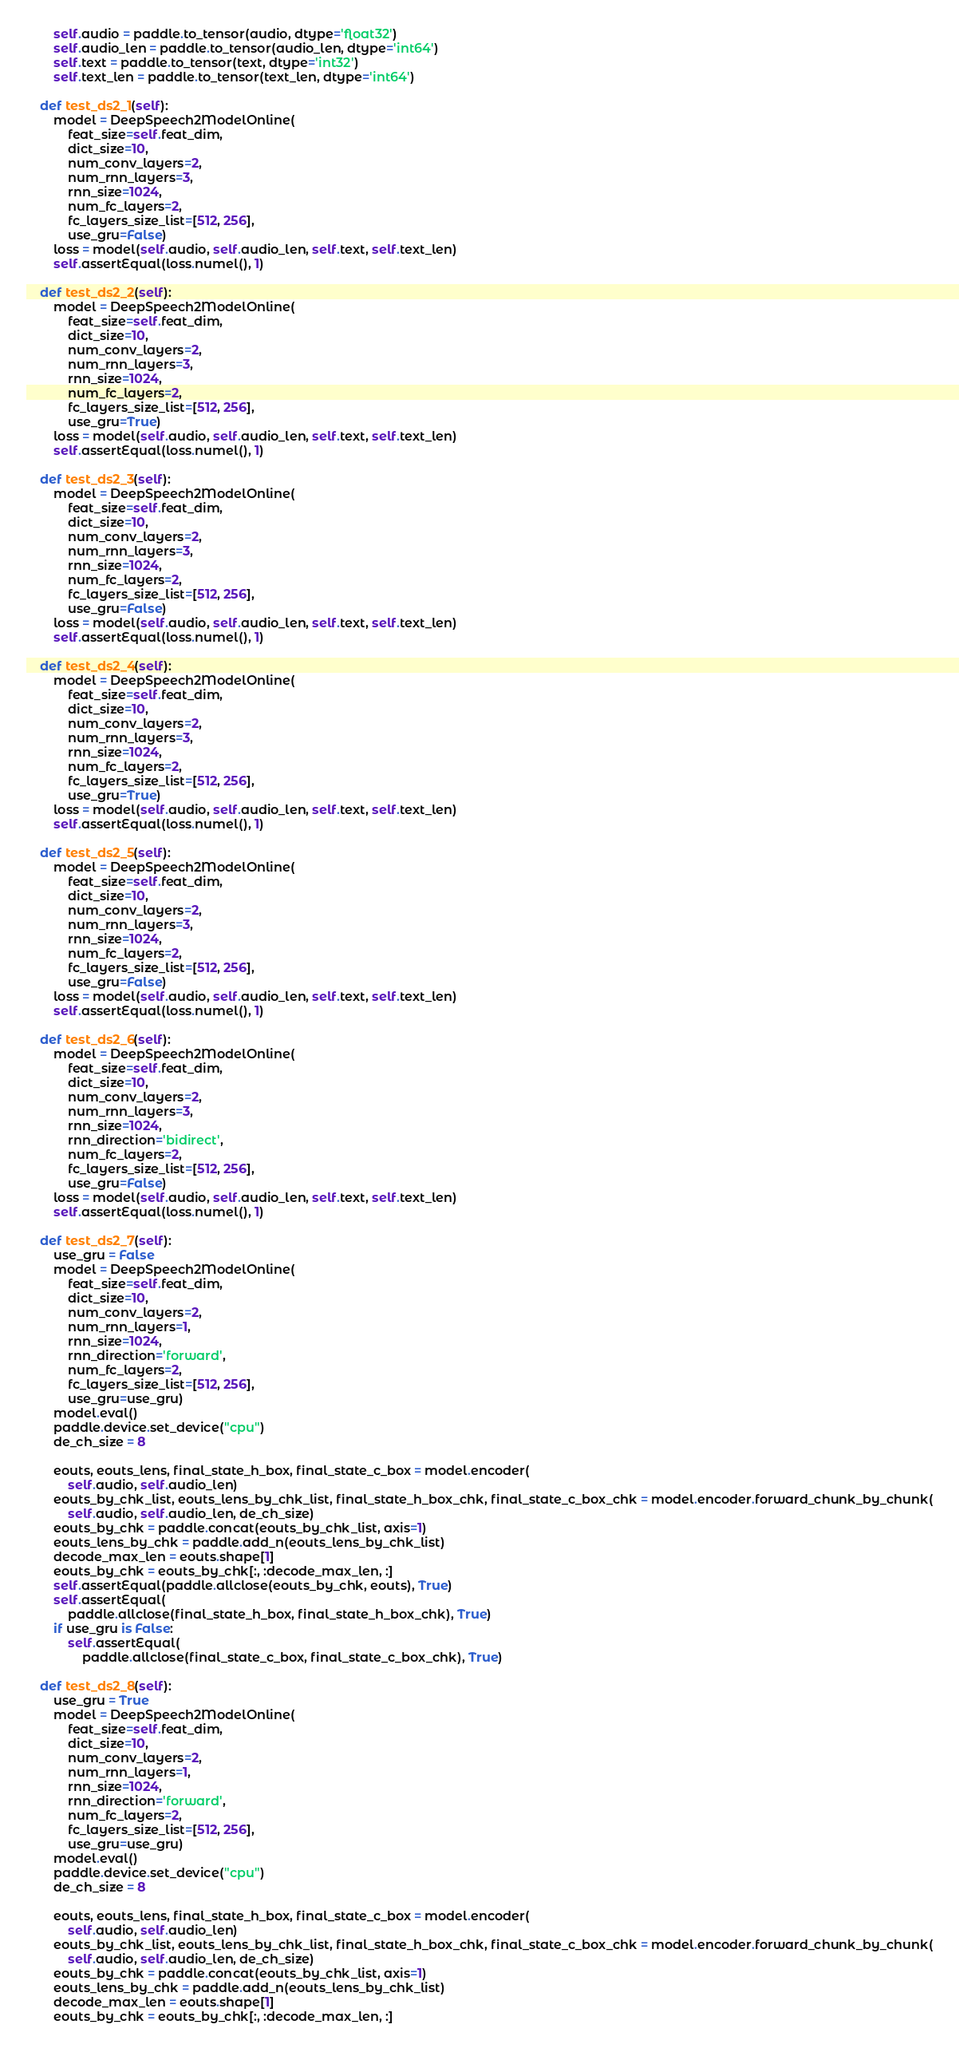<code> <loc_0><loc_0><loc_500><loc_500><_Python_>
        self.audio = paddle.to_tensor(audio, dtype='float32')
        self.audio_len = paddle.to_tensor(audio_len, dtype='int64')
        self.text = paddle.to_tensor(text, dtype='int32')
        self.text_len = paddle.to_tensor(text_len, dtype='int64')

    def test_ds2_1(self):
        model = DeepSpeech2ModelOnline(
            feat_size=self.feat_dim,
            dict_size=10,
            num_conv_layers=2,
            num_rnn_layers=3,
            rnn_size=1024,
            num_fc_layers=2,
            fc_layers_size_list=[512, 256],
            use_gru=False)
        loss = model(self.audio, self.audio_len, self.text, self.text_len)
        self.assertEqual(loss.numel(), 1)

    def test_ds2_2(self):
        model = DeepSpeech2ModelOnline(
            feat_size=self.feat_dim,
            dict_size=10,
            num_conv_layers=2,
            num_rnn_layers=3,
            rnn_size=1024,
            num_fc_layers=2,
            fc_layers_size_list=[512, 256],
            use_gru=True)
        loss = model(self.audio, self.audio_len, self.text, self.text_len)
        self.assertEqual(loss.numel(), 1)

    def test_ds2_3(self):
        model = DeepSpeech2ModelOnline(
            feat_size=self.feat_dim,
            dict_size=10,
            num_conv_layers=2,
            num_rnn_layers=3,
            rnn_size=1024,
            num_fc_layers=2,
            fc_layers_size_list=[512, 256],
            use_gru=False)
        loss = model(self.audio, self.audio_len, self.text, self.text_len)
        self.assertEqual(loss.numel(), 1)

    def test_ds2_4(self):
        model = DeepSpeech2ModelOnline(
            feat_size=self.feat_dim,
            dict_size=10,
            num_conv_layers=2,
            num_rnn_layers=3,
            rnn_size=1024,
            num_fc_layers=2,
            fc_layers_size_list=[512, 256],
            use_gru=True)
        loss = model(self.audio, self.audio_len, self.text, self.text_len)
        self.assertEqual(loss.numel(), 1)

    def test_ds2_5(self):
        model = DeepSpeech2ModelOnline(
            feat_size=self.feat_dim,
            dict_size=10,
            num_conv_layers=2,
            num_rnn_layers=3,
            rnn_size=1024,
            num_fc_layers=2,
            fc_layers_size_list=[512, 256],
            use_gru=False)
        loss = model(self.audio, self.audio_len, self.text, self.text_len)
        self.assertEqual(loss.numel(), 1)

    def test_ds2_6(self):
        model = DeepSpeech2ModelOnline(
            feat_size=self.feat_dim,
            dict_size=10,
            num_conv_layers=2,
            num_rnn_layers=3,
            rnn_size=1024,
            rnn_direction='bidirect',
            num_fc_layers=2,
            fc_layers_size_list=[512, 256],
            use_gru=False)
        loss = model(self.audio, self.audio_len, self.text, self.text_len)
        self.assertEqual(loss.numel(), 1)

    def test_ds2_7(self):
        use_gru = False
        model = DeepSpeech2ModelOnline(
            feat_size=self.feat_dim,
            dict_size=10,
            num_conv_layers=2,
            num_rnn_layers=1,
            rnn_size=1024,
            rnn_direction='forward',
            num_fc_layers=2,
            fc_layers_size_list=[512, 256],
            use_gru=use_gru)
        model.eval()
        paddle.device.set_device("cpu")
        de_ch_size = 8

        eouts, eouts_lens, final_state_h_box, final_state_c_box = model.encoder(
            self.audio, self.audio_len)
        eouts_by_chk_list, eouts_lens_by_chk_list, final_state_h_box_chk, final_state_c_box_chk = model.encoder.forward_chunk_by_chunk(
            self.audio, self.audio_len, de_ch_size)
        eouts_by_chk = paddle.concat(eouts_by_chk_list, axis=1)
        eouts_lens_by_chk = paddle.add_n(eouts_lens_by_chk_list)
        decode_max_len = eouts.shape[1]
        eouts_by_chk = eouts_by_chk[:, :decode_max_len, :]
        self.assertEqual(paddle.allclose(eouts_by_chk, eouts), True)
        self.assertEqual(
            paddle.allclose(final_state_h_box, final_state_h_box_chk), True)
        if use_gru is False:
            self.assertEqual(
                paddle.allclose(final_state_c_box, final_state_c_box_chk), True)

    def test_ds2_8(self):
        use_gru = True
        model = DeepSpeech2ModelOnline(
            feat_size=self.feat_dim,
            dict_size=10,
            num_conv_layers=2,
            num_rnn_layers=1,
            rnn_size=1024,
            rnn_direction='forward',
            num_fc_layers=2,
            fc_layers_size_list=[512, 256],
            use_gru=use_gru)
        model.eval()
        paddle.device.set_device("cpu")
        de_ch_size = 8

        eouts, eouts_lens, final_state_h_box, final_state_c_box = model.encoder(
            self.audio, self.audio_len)
        eouts_by_chk_list, eouts_lens_by_chk_list, final_state_h_box_chk, final_state_c_box_chk = model.encoder.forward_chunk_by_chunk(
            self.audio, self.audio_len, de_ch_size)
        eouts_by_chk = paddle.concat(eouts_by_chk_list, axis=1)
        eouts_lens_by_chk = paddle.add_n(eouts_lens_by_chk_list)
        decode_max_len = eouts.shape[1]
        eouts_by_chk = eouts_by_chk[:, :decode_max_len, :]</code> 